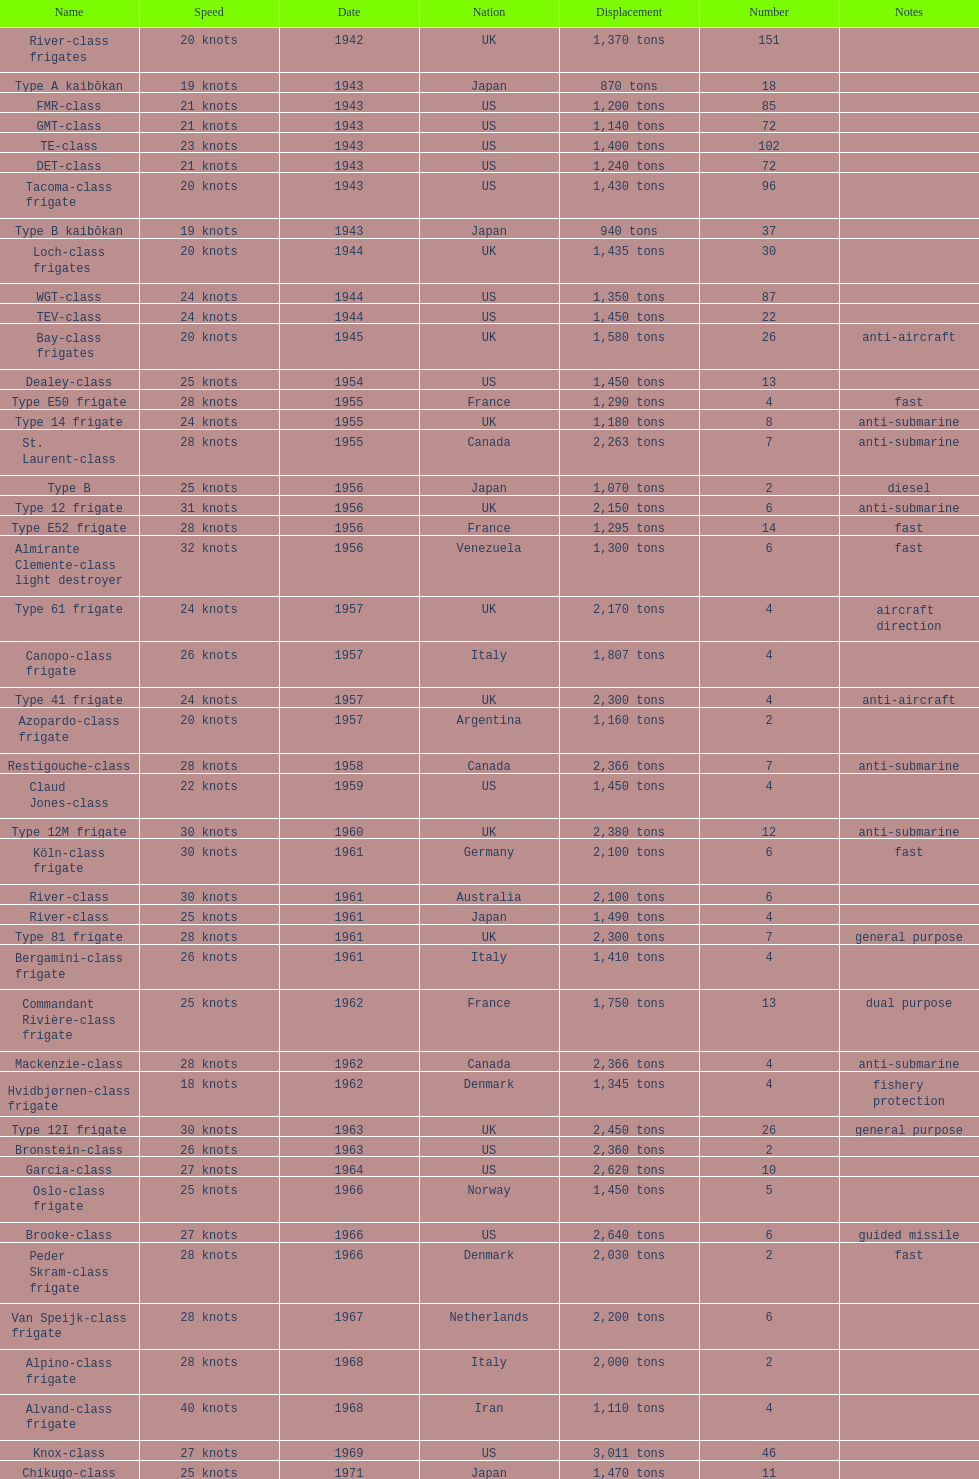Would you mind parsing the complete table? {'header': ['Name', 'Speed', 'Date', 'Nation', 'Displacement', 'Number', 'Notes'], 'rows': [['River-class frigates', '20 knots', '1942', 'UK', '1,370 tons', '151', ''], ['Type A kaibōkan', '19 knots', '1943', 'Japan', '870 tons', '18', ''], ['FMR-class', '21 knots', '1943', 'US', '1,200 tons', '85', ''], ['GMT-class', '21 knots', '1943', 'US', '1,140 tons', '72', ''], ['TE-class', '23 knots', '1943', 'US', '1,400 tons', '102', ''], ['DET-class', '21 knots', '1943', 'US', '1,240 tons', '72', ''], ['Tacoma-class frigate', '20 knots', '1943', 'US', '1,430 tons', '96', ''], ['Type B kaibōkan', '19 knots', '1943', 'Japan', '940 tons', '37', ''], ['Loch-class frigates', '20 knots', '1944', 'UK', '1,435 tons', '30', ''], ['WGT-class', '24 knots', '1944', 'US', '1,350 tons', '87', ''], ['TEV-class', '24 knots', '1944', 'US', '1,450 tons', '22', ''], ['Bay-class frigates', '20 knots', '1945', 'UK', '1,580 tons', '26', 'anti-aircraft'], ['Dealey-class', '25 knots', '1954', 'US', '1,450 tons', '13', ''], ['Type E50 frigate', '28 knots', '1955', 'France', '1,290 tons', '4', 'fast'], ['Type 14 frigate', '24 knots', '1955', 'UK', '1,180 tons', '8', 'anti-submarine'], ['St. Laurent-class', '28 knots', '1955', 'Canada', '2,263 tons', '7', 'anti-submarine'], ['Type B', '25 knots', '1956', 'Japan', '1,070 tons', '2', 'diesel'], ['Type 12 frigate', '31 knots', '1956', 'UK', '2,150 tons', '6', 'anti-submarine'], ['Type E52 frigate', '28 knots', '1956', 'France', '1,295 tons', '14', 'fast'], ['Almirante Clemente-class light destroyer', '32 knots', '1956', 'Venezuela', '1,300 tons', '6', 'fast'], ['Type 61 frigate', '24 knots', '1957', 'UK', '2,170 tons', '4', 'aircraft direction'], ['Canopo-class frigate', '26 knots', '1957', 'Italy', '1,807 tons', '4', ''], ['Type 41 frigate', '24 knots', '1957', 'UK', '2,300 tons', '4', 'anti-aircraft'], ['Azopardo-class frigate', '20 knots', '1957', 'Argentina', '1,160 tons', '2', ''], ['Restigouche-class', '28 knots', '1958', 'Canada', '2,366 tons', '7', 'anti-submarine'], ['Claud Jones-class', '22 knots', '1959', 'US', '1,450 tons', '4', ''], ['Type 12M frigate', '30 knots', '1960', 'UK', '2,380 tons', '12', 'anti-submarine'], ['Köln-class frigate', '30 knots', '1961', 'Germany', '2,100 tons', '6', 'fast'], ['River-class', '30 knots', '1961', 'Australia', '2,100 tons', '6', ''], ['River-class', '25 knots', '1961', 'Japan', '1,490 tons', '4', ''], ['Type 81 frigate', '28 knots', '1961', 'UK', '2,300 tons', '7', 'general purpose'], ['Bergamini-class frigate', '26 knots', '1961', 'Italy', '1,410 tons', '4', ''], ['Commandant Rivière-class frigate', '25 knots', '1962', 'France', '1,750 tons', '13', 'dual purpose'], ['Mackenzie-class', '28 knots', '1962', 'Canada', '2,366 tons', '4', 'anti-submarine'], ['Hvidbjørnen-class frigate', '18 knots', '1962', 'Denmark', '1,345 tons', '4', 'fishery protection'], ['Type 12I frigate', '30 knots', '1963', 'UK', '2,450 tons', '26', 'general purpose'], ['Bronstein-class', '26 knots', '1963', 'US', '2,360 tons', '2', ''], ['Garcia-class', '27 knots', '1964', 'US', '2,620 tons', '10', ''], ['Oslo-class frigate', '25 knots', '1966', 'Norway', '1,450 tons', '5', ''], ['Brooke-class', '27 knots', '1966', 'US', '2,640 tons', '6', 'guided missile'], ['Peder Skram-class frigate', '28 knots', '1966', 'Denmark', '2,030 tons', '2', 'fast'], ['Van Speijk-class frigate', '28 knots', '1967', 'Netherlands', '2,200 tons', '6', ''], ['Alpino-class frigate', '28 knots', '1968', 'Italy', '2,000 tons', '2', ''], ['Alvand-class frigate', '40 knots', '1968', 'Iran', '1,110 tons', '4', ''], ['Knox-class', '27 knots', '1969', 'US', '3,011 tons', '46', ''], ['Chikugo-class', '25 knots', '1971', 'Japan', '1,470 tons', '11', '']]} In 1968 italy used alpino-class frigate. what was its top speed? 28 knots. 